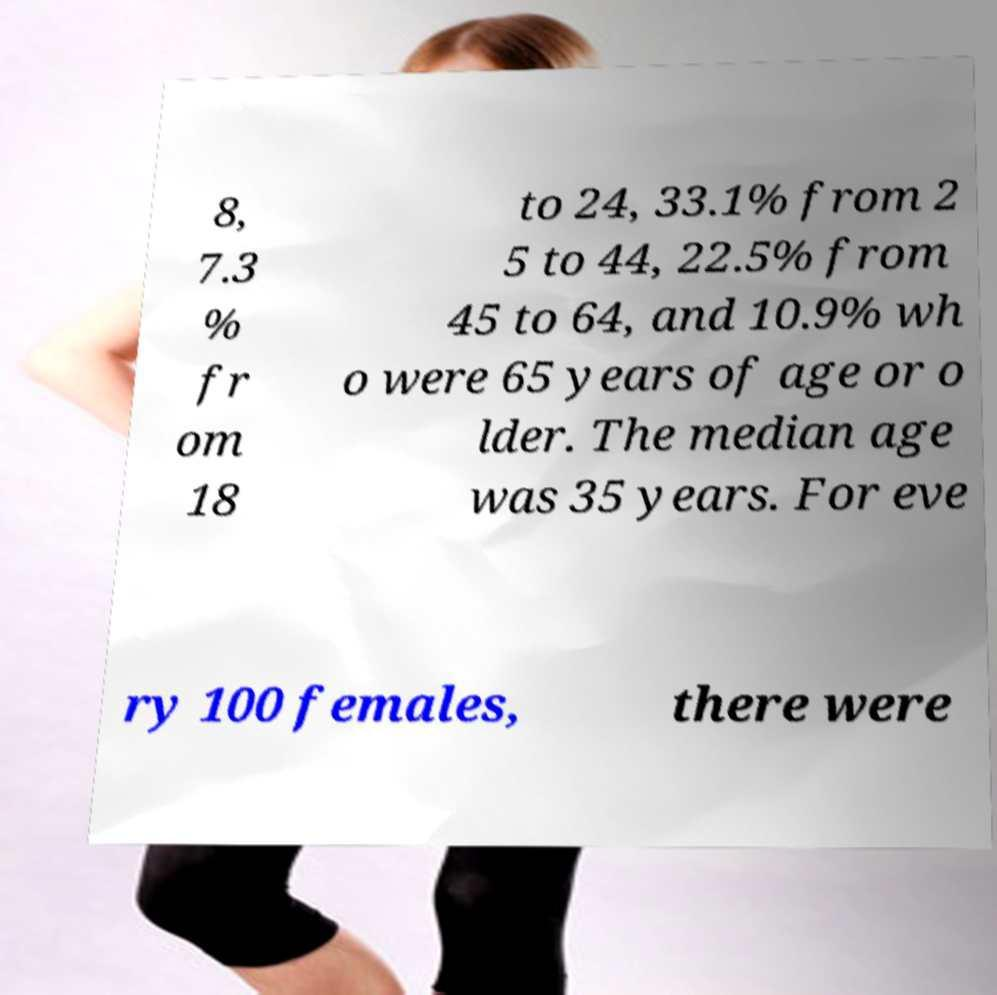Please identify and transcribe the text found in this image. 8, 7.3 % fr om 18 to 24, 33.1% from 2 5 to 44, 22.5% from 45 to 64, and 10.9% wh o were 65 years of age or o lder. The median age was 35 years. For eve ry 100 females, there were 